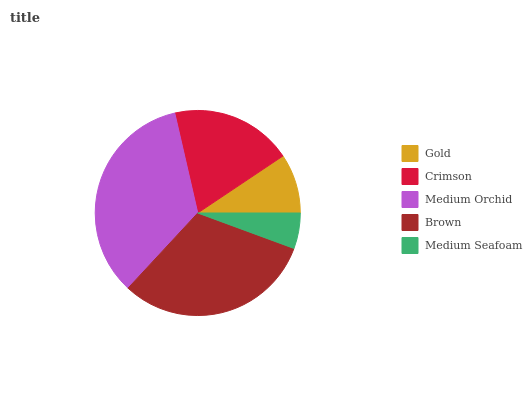Is Medium Seafoam the minimum?
Answer yes or no. Yes. Is Medium Orchid the maximum?
Answer yes or no. Yes. Is Crimson the minimum?
Answer yes or no. No. Is Crimson the maximum?
Answer yes or no. No. Is Crimson greater than Gold?
Answer yes or no. Yes. Is Gold less than Crimson?
Answer yes or no. Yes. Is Gold greater than Crimson?
Answer yes or no. No. Is Crimson less than Gold?
Answer yes or no. No. Is Crimson the high median?
Answer yes or no. Yes. Is Crimson the low median?
Answer yes or no. Yes. Is Gold the high median?
Answer yes or no. No. Is Medium Orchid the low median?
Answer yes or no. No. 